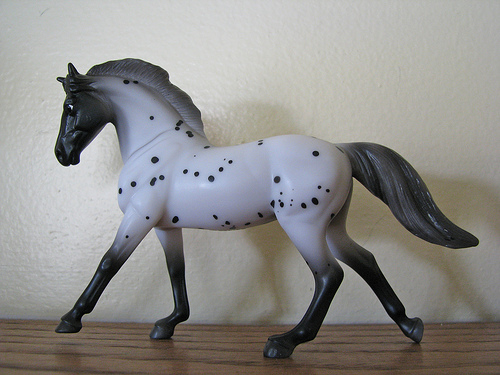<image>
Is there a horse on the table? Yes. Looking at the image, I can see the horse is positioned on top of the table, with the table providing support. Is there a toy in front of the wall? Yes. The toy is positioned in front of the wall, appearing closer to the camera viewpoint. 